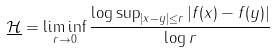Convert formula to latex. <formula><loc_0><loc_0><loc_500><loc_500>\underline { \mathcal { H } } = \liminf _ { r \to 0 } \frac { \log \sup _ { | x - y | \leq r } | f ( x ) - f ( y ) | } { \log r }</formula> 